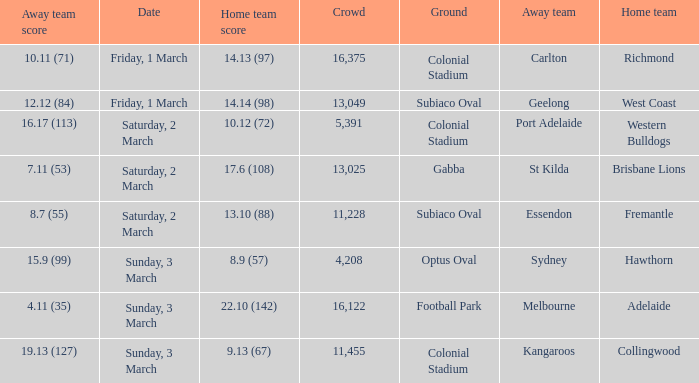When was the away team geelong? Friday, 1 March. 